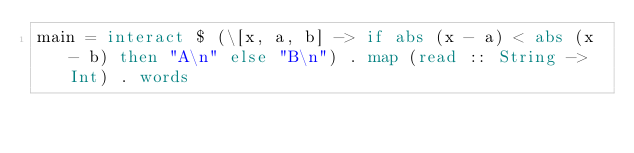Convert code to text. <code><loc_0><loc_0><loc_500><loc_500><_Haskell_>main = interact $ (\[x, a, b] -> if abs (x - a) < abs (x - b) then "A\n" else "B\n") . map (read :: String -> Int) . words
</code> 